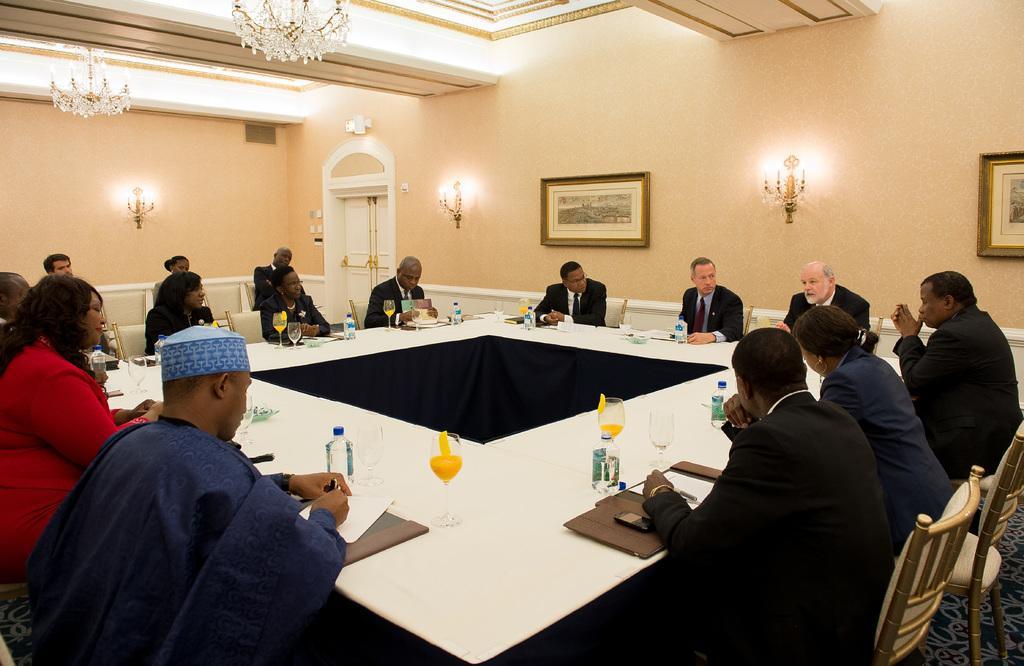Could you give a brief overview of what you see in this image? There is a group of people. They are sitting around the table. This man is sitting on the chair. He is in black color suit. This woman is in red color dress. These are the bottles on the table. These are the juices on the table. This is the glass. This is the mobile. This is the wall. This is the photo frame. This is the light. This is the door. And this is the floor 